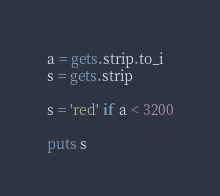Convert code to text. <code><loc_0><loc_0><loc_500><loc_500><_Ruby_>a = gets.strip.to_i
s = gets.strip

s = 'red' if a < 3200

puts s</code> 